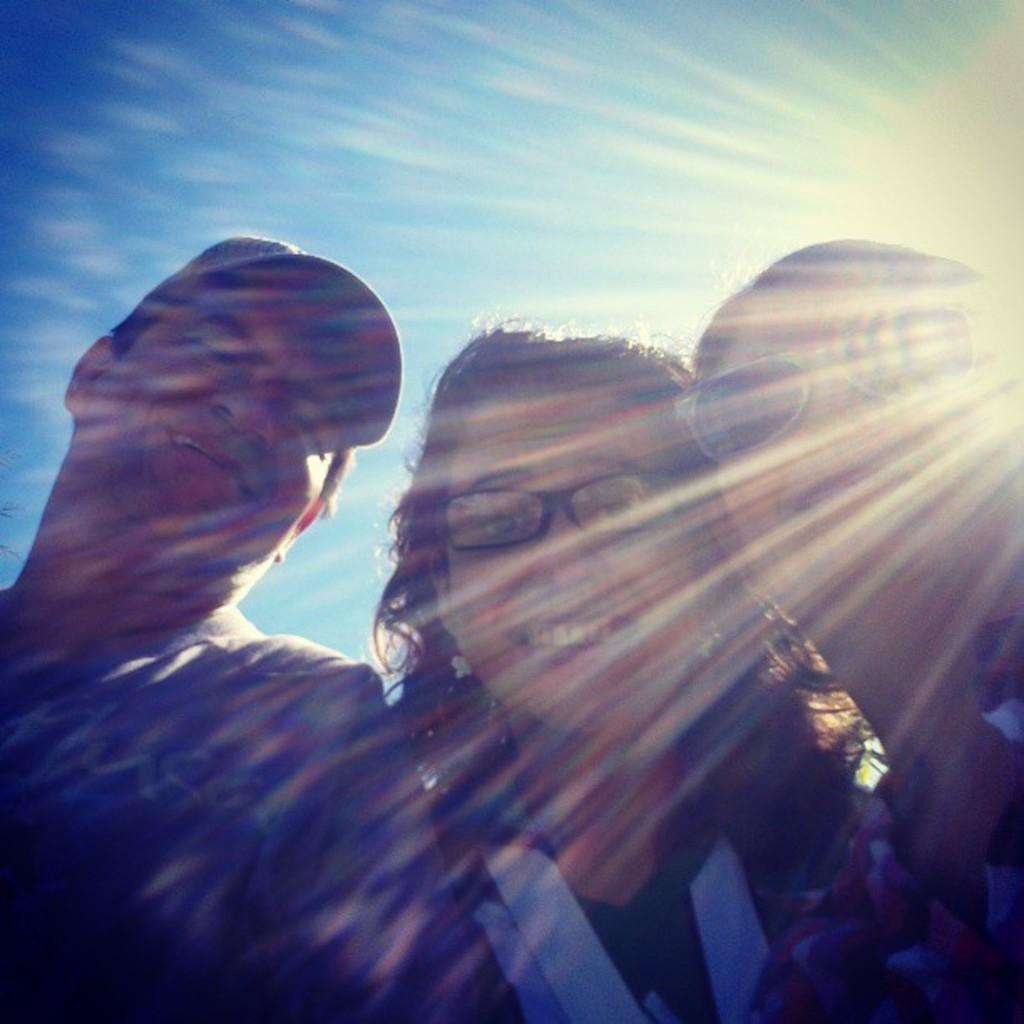How many people are in the image? There is a group of people in the image. What are some of the people wearing? Some of the people are wearing dresses. Can you describe the eyewear of two different people in the image? One person is wearing specs, and another person is wearing goggles. What can be seen in the background of the image? The sky is visible in the background of the image. What letters are being held by the rat in the image? There is no rat present in the image, and therefore no letters can be held by it. 